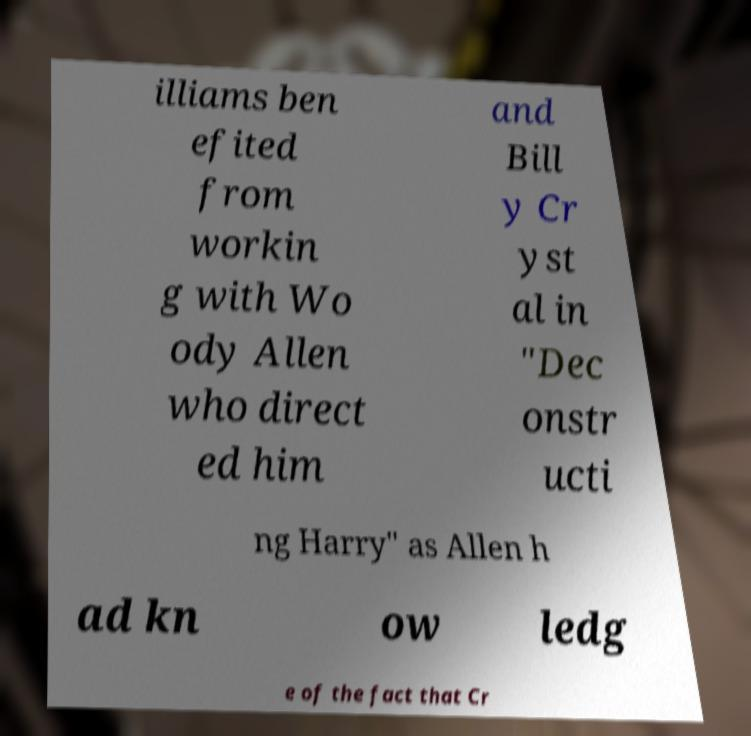Can you accurately transcribe the text from the provided image for me? illiams ben efited from workin g with Wo ody Allen who direct ed him and Bill y Cr yst al in "Dec onstr ucti ng Harry" as Allen h ad kn ow ledg e of the fact that Cr 